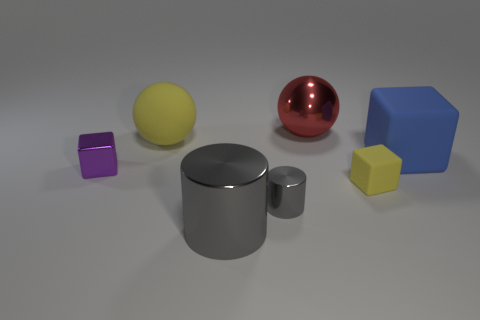Is the tiny matte object the same color as the large matte ball?
Your response must be concise. Yes. There is a matte block that is on the right side of the yellow cube; does it have the same size as the purple shiny object?
Make the answer very short. No. What is the shape of the large object that is right of the large gray metal cylinder and behind the large matte cube?
Provide a short and direct response. Sphere. Are there more yellow things that are behind the blue rubber cube than tiny yellow cylinders?
Keep it short and to the point. Yes. There is a red object that is made of the same material as the small purple thing; what is its size?
Provide a short and direct response. Large. What number of tiny objects are the same color as the small matte block?
Give a very brief answer. 0. Is the color of the matte cube that is in front of the blue matte object the same as the matte sphere?
Make the answer very short. Yes. Is the number of yellow cubes behind the red thing the same as the number of small purple metallic objects right of the small yellow rubber cube?
Offer a terse response. Yes. What is the color of the sphere that is to the left of the large gray cylinder?
Ensure brevity in your answer.  Yellow. Is the number of gray metal objects that are in front of the tiny purple object the same as the number of big rubber objects?
Ensure brevity in your answer.  Yes. 